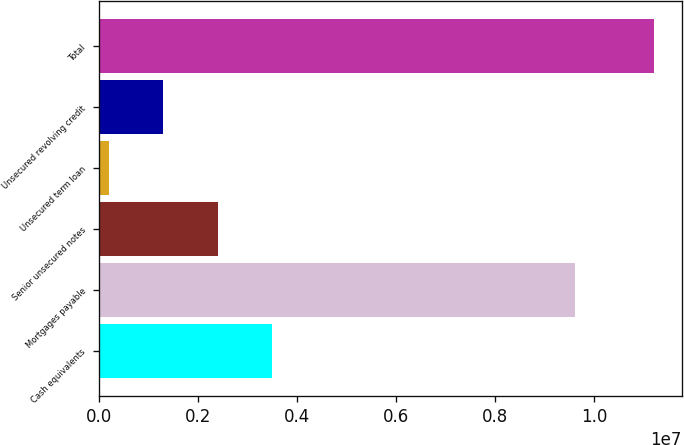<chart> <loc_0><loc_0><loc_500><loc_500><bar_chart><fcel>Cash equivalents<fcel>Mortgages payable<fcel>Senior unsecured notes<fcel>Unsecured term loan<fcel>Unsecured revolving credit<fcel>Total<nl><fcel>3.49195e+06<fcel>9.61484e+06<fcel>2.39047e+06<fcel>187500<fcel>1.28898e+06<fcel>1.12023e+07<nl></chart> 